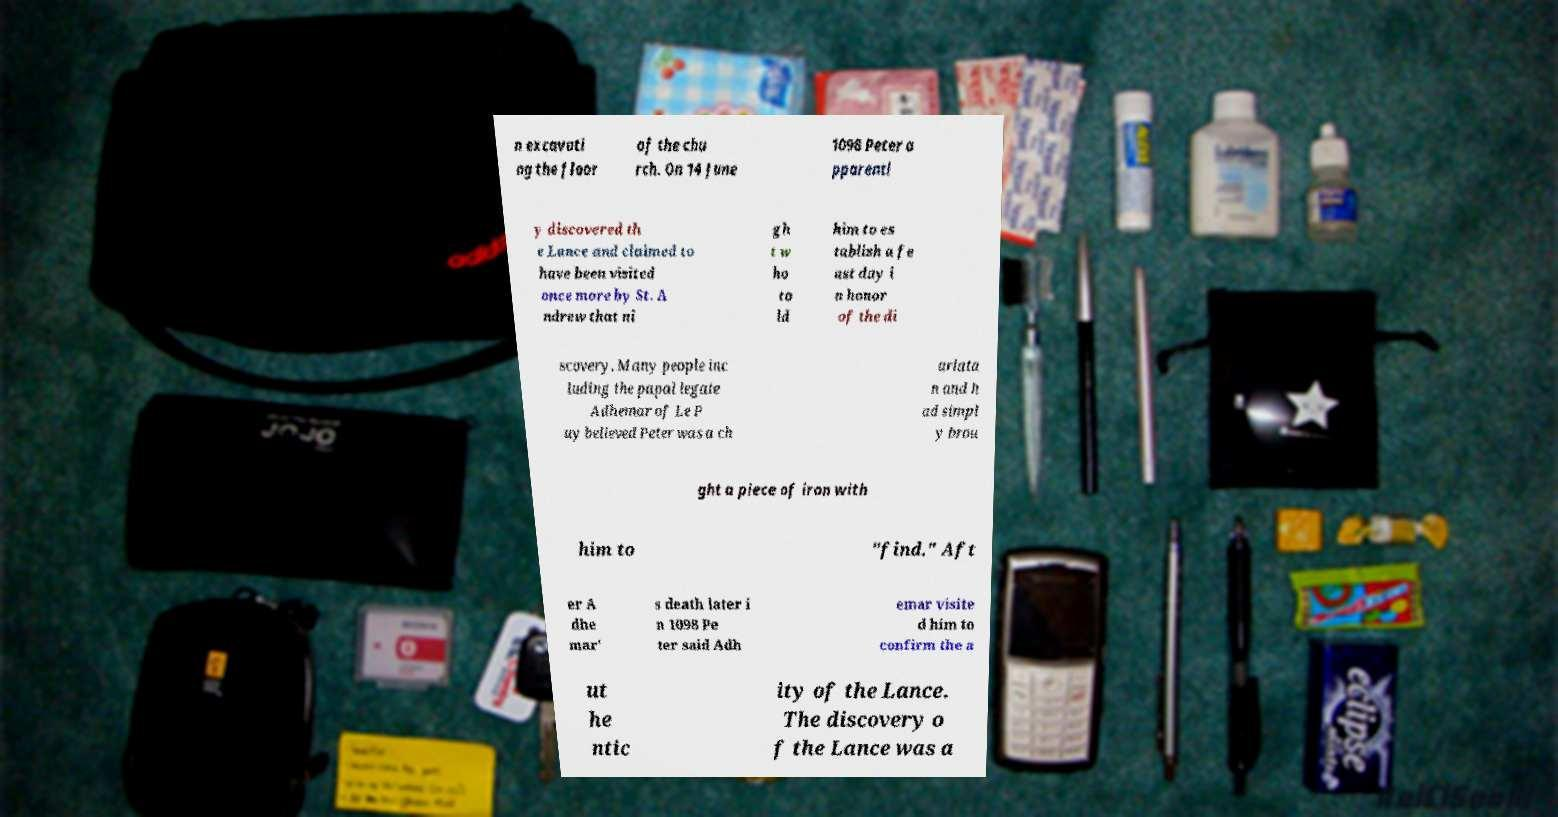Could you extract and type out the text from this image? n excavati ng the floor of the chu rch. On 14 June 1098 Peter a pparentl y discovered th e Lance and claimed to have been visited once more by St. A ndrew that ni gh t w ho to ld him to es tablish a fe ast day i n honor of the di scovery. Many people inc luding the papal legate Adhemar of Le P uy believed Peter was a ch arlata n and h ad simpl y brou ght a piece of iron with him to "find." Aft er A dhe mar' s death later i n 1098 Pe ter said Adh emar visite d him to confirm the a ut he ntic ity of the Lance. The discovery o f the Lance was a 